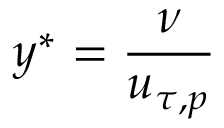Convert formula to latex. <formula><loc_0><loc_0><loc_500><loc_500>y ^ { * } = \frac { \nu } { u _ { \tau , p } }</formula> 